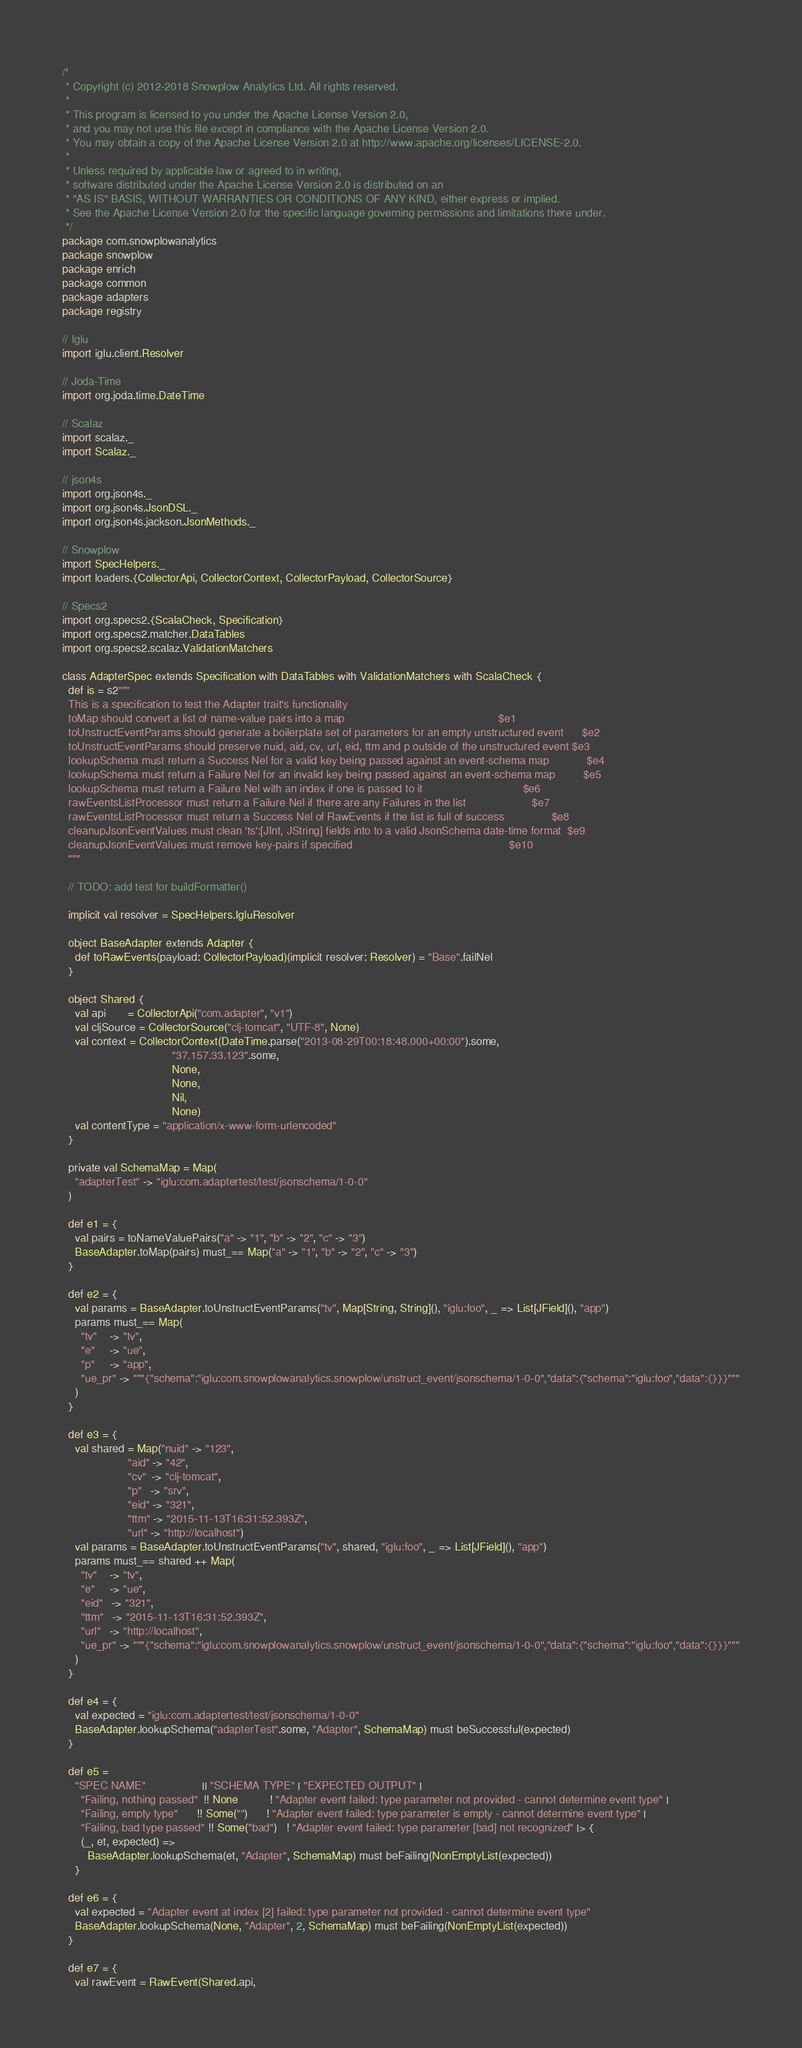Convert code to text. <code><loc_0><loc_0><loc_500><loc_500><_Scala_>/*
 * Copyright (c) 2012-2018 Snowplow Analytics Ltd. All rights reserved.
 *
 * This program is licensed to you under the Apache License Version 2.0,
 * and you may not use this file except in compliance with the Apache License Version 2.0.
 * You may obtain a copy of the Apache License Version 2.0 at http://www.apache.org/licenses/LICENSE-2.0.
 *
 * Unless required by applicable law or agreed to in writing,
 * software distributed under the Apache License Version 2.0 is distributed on an
 * "AS IS" BASIS, WITHOUT WARRANTIES OR CONDITIONS OF ANY KIND, either express or implied.
 * See the Apache License Version 2.0 for the specific language governing permissions and limitations there under.
 */
package com.snowplowanalytics
package snowplow
package enrich
package common
package adapters
package registry

// Iglu
import iglu.client.Resolver

// Joda-Time
import org.joda.time.DateTime

// Scalaz
import scalaz._
import Scalaz._

// json4s
import org.json4s._
import org.json4s.JsonDSL._
import org.json4s.jackson.JsonMethods._

// Snowplow
import SpecHelpers._
import loaders.{CollectorApi, CollectorContext, CollectorPayload, CollectorSource}

// Specs2
import org.specs2.{ScalaCheck, Specification}
import org.specs2.matcher.DataTables
import org.specs2.scalaz.ValidationMatchers

class AdapterSpec extends Specification with DataTables with ValidationMatchers with ScalaCheck {
  def is = s2"""
  This is a specification to test the Adapter trait's functionality
  toMap should convert a list of name-value pairs into a map                                                 $e1
  toUnstructEventParams should generate a boilerplate set of parameters for an empty unstructured event      $e2
  toUnstructEventParams should preserve nuid, aid, cv, url, eid, ttm and p outside of the unstructured event $e3
  lookupSchema must return a Success Nel for a valid key being passed against an event-schema map            $e4
  lookupSchema must return a Failure Nel for an invalid key being passed against an event-schema map         $e5
  lookupSchema must return a Failure Nel with an index if one is passed to it                                $e6
  rawEventsListProcessor must return a Failure Nel if there are any Failures in the list                     $e7
  rawEventsListProcessor must return a Success Nel of RawEvents if the list is full of success               $e8
  cleanupJsonEventValues must clean 'ts':[JInt, JString] fields into to a valid JsonSchema date-time format  $e9
  cleanupJsonEventValues must remove key-pairs if specified                                                  $e10
  """

  // TODO: add test for buildFormatter()

  implicit val resolver = SpecHelpers.IgluResolver

  object BaseAdapter extends Adapter {
    def toRawEvents(payload: CollectorPayload)(implicit resolver: Resolver) = "Base".failNel
  }

  object Shared {
    val api       = CollectorApi("com.adapter", "v1")
    val cljSource = CollectorSource("clj-tomcat", "UTF-8", None)
    val context = CollectorContext(DateTime.parse("2013-08-29T00:18:48.000+00:00").some,
                                   "37.157.33.123".some,
                                   None,
                                   None,
                                   Nil,
                                   None)
    val contentType = "application/x-www-form-urlencoded"
  }

  private val SchemaMap = Map(
    "adapterTest" -> "iglu:com.adaptertest/test/jsonschema/1-0-0"
  )

  def e1 = {
    val pairs = toNameValuePairs("a" -> "1", "b" -> "2", "c" -> "3")
    BaseAdapter.toMap(pairs) must_== Map("a" -> "1", "b" -> "2", "c" -> "3")
  }

  def e2 = {
    val params = BaseAdapter.toUnstructEventParams("tv", Map[String, String](), "iglu:foo", _ => List[JField](), "app")
    params must_== Map(
      "tv"    -> "tv",
      "e"     -> "ue",
      "p"     -> "app",
      "ue_pr" -> """{"schema":"iglu:com.snowplowanalytics.snowplow/unstruct_event/jsonschema/1-0-0","data":{"schema":"iglu:foo","data":{}}}"""
    )
  }

  def e3 = {
    val shared = Map("nuid" -> "123",
                     "aid" -> "42",
                     "cv"  -> "clj-tomcat",
                     "p"   -> "srv",
                     "eid" -> "321",
                     "ttm" -> "2015-11-13T16:31:52.393Z",
                     "url" -> "http://localhost")
    val params = BaseAdapter.toUnstructEventParams("tv", shared, "iglu:foo", _ => List[JField](), "app")
    params must_== shared ++ Map(
      "tv"    -> "tv",
      "e"     -> "ue",
      "eid"   -> "321",
      "ttm"   -> "2015-11-13T16:31:52.393Z",
      "url"   -> "http://localhost",
      "ue_pr" -> """{"schema":"iglu:com.snowplowanalytics.snowplow/unstruct_event/jsonschema/1-0-0","data":{"schema":"iglu:foo","data":{}}}"""
    )
  }

  def e4 = {
    val expected = "iglu:com.adaptertest/test/jsonschema/1-0-0"
    BaseAdapter.lookupSchema("adapterTest".some, "Adapter", SchemaMap) must beSuccessful(expected)
  }

  def e5 =
    "SPEC NAME"                  || "SCHEMA TYPE" | "EXPECTED OUTPUT" |
      "Failing, nothing passed"  !! None          ! "Adapter event failed: type parameter not provided - cannot determine event type" |
      "Failing, empty type"      !! Some("")      ! "Adapter event failed: type parameter is empty - cannot determine event type" |
      "Failing, bad type passed" !! Some("bad")   ! "Adapter event failed: type parameter [bad] not recognized" |> {
      (_, et, expected) =>
        BaseAdapter.lookupSchema(et, "Adapter", SchemaMap) must beFailing(NonEmptyList(expected))
    }

  def e6 = {
    val expected = "Adapter event at index [2] failed: type parameter not provided - cannot determine event type"
    BaseAdapter.lookupSchema(None, "Adapter", 2, SchemaMap) must beFailing(NonEmptyList(expected))
  }

  def e7 = {
    val rawEvent = RawEvent(Shared.api,</code> 